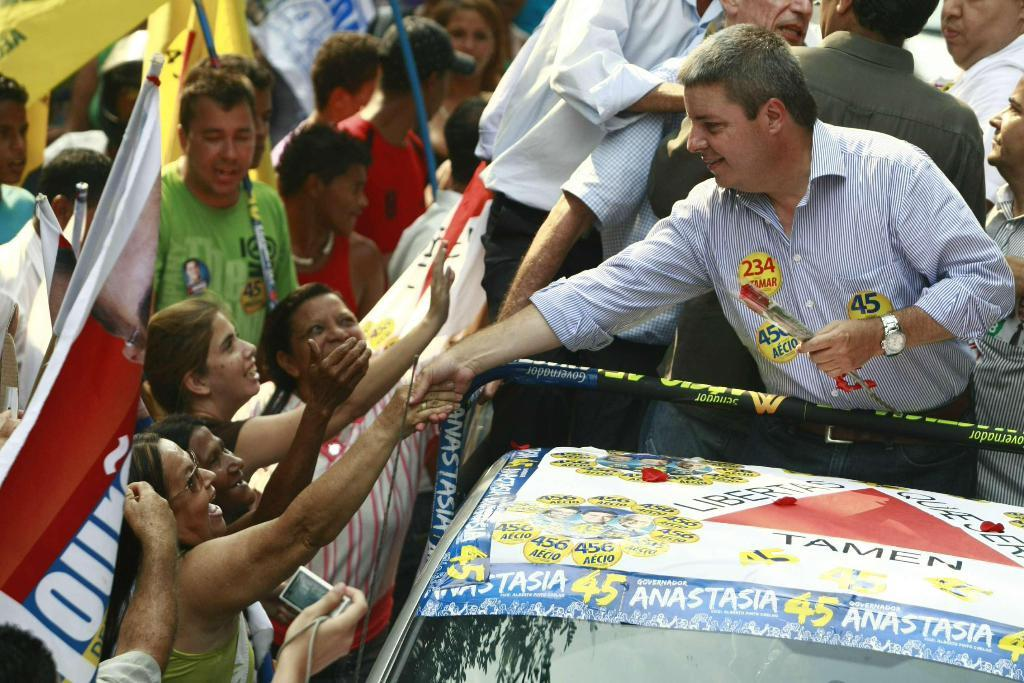How many people are in the image? There are people in the image, but the exact number is not specified. Can you describe the expressions of the people in the image? Some people in the image are smiling. What else can be seen in the image besides people? There are flags and text visible in the image. What type of work does the maid do in the image? There is no maid present in the image. What type of tools does the carpenter use in the image? There is no carpenter present in the image. What type of decisions does the manager make in the image? There is no manager present in the image. 